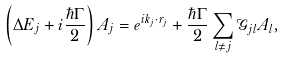<formula> <loc_0><loc_0><loc_500><loc_500>\left ( \Delta E _ { j } + i \frac { \hbar { \Gamma } } { 2 } \right ) A _ { j } = e ^ { i k _ { j } \cdot r _ { j } } + \frac { \hbar { \Gamma } } { 2 } \sum _ { l \neq j } \mathcal { G } _ { j l } A _ { l } ,</formula> 